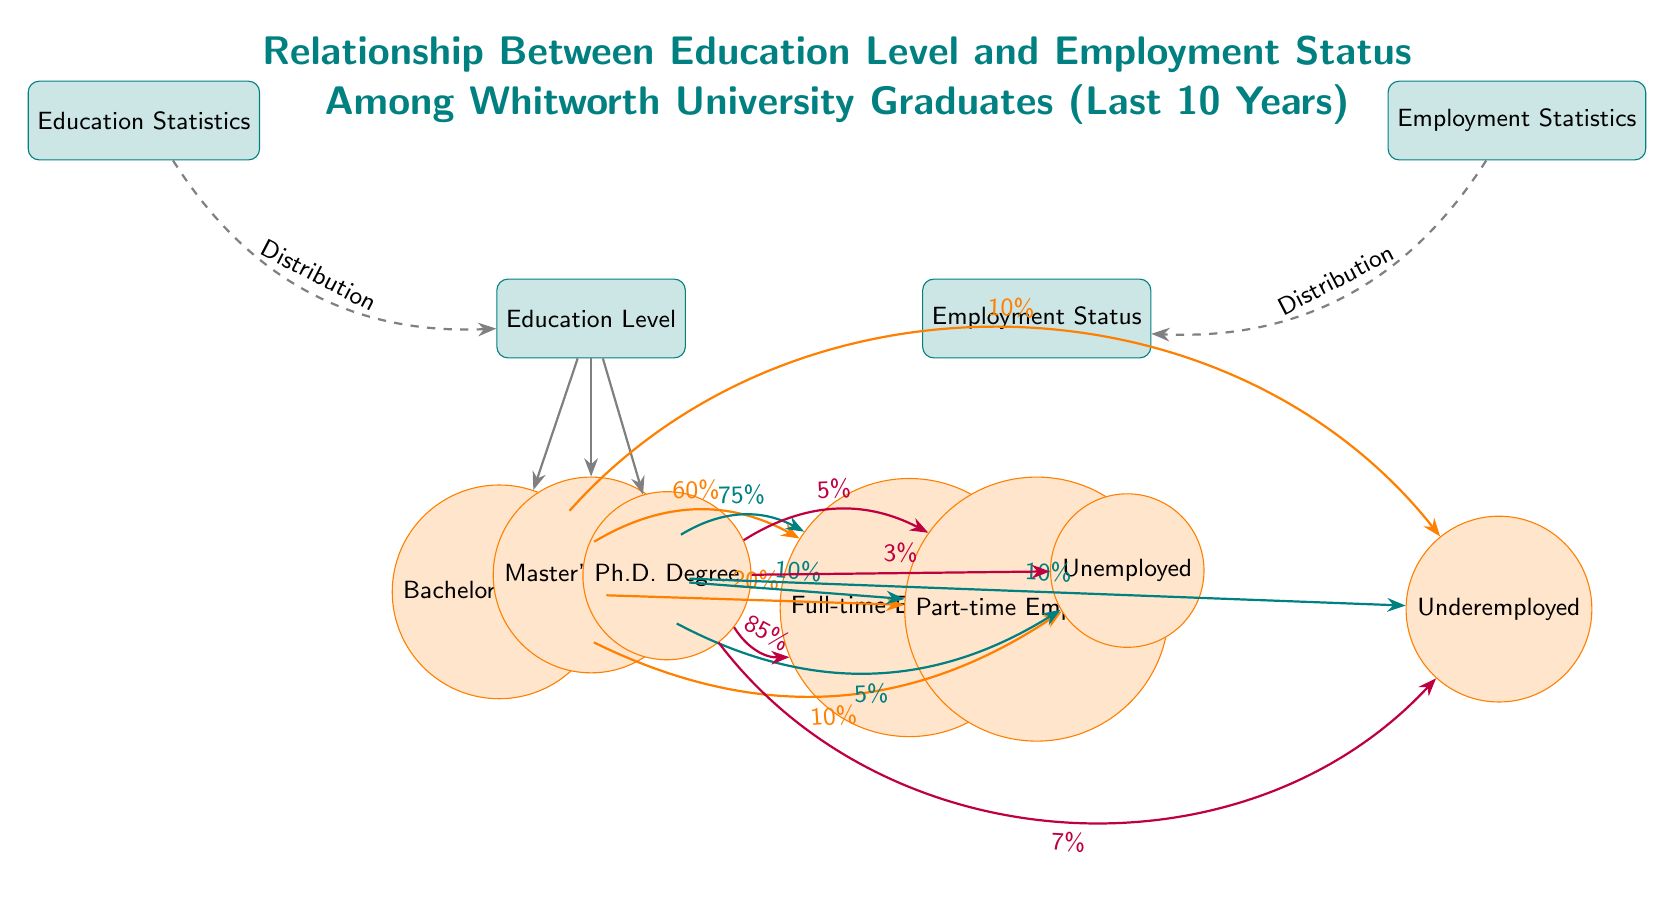What is the total number of education levels shown in the diagram? The diagram depicts three education levels: Bachelor's Degree, Master's Degree, and Ph.D. Degree.
Answer: 3 What percentage of Bachelor's Degree holders are unemployed? According to the diagram, 10% of the Bachelor's Degree holders fall into the unemployed category.
Answer: 10% Which education level leads to the lowest percentage of full-time employment? The Bachelor's Degree leads to 60% full-time employment, which is lower than the Master's (75%) and Ph.D. (85%) levels.
Answer: Bachelor's Degree How many employment statuses are represented in the diagram? The diagram illustrates four employment statuses: Full-time Employment, Part-time Employment, Unemployed, and Underemployed; thus, there are four statuses.
Answer: 4 What percentage of Master's Degree holders are underemployed? The diagram indicates that 10% of Master's Degree holders are categorized as underemployed.
Answer: 10% Which employment status has the highest percentage among Ph.D. Degree holders? The highest percentage among Ph.D. Degree holders is in Full-time Employment, with 85%.
Answer: 85% What conclusion can be drawn about employment status as education level increases? As education level increases, the percentage of individuals in Full-time Employment rises, while Unemployment rates decrease.
Answer: Increases in education lead to higher full-time employment and lower unemployment What is the connection between Education Statistics and Employment Statistics in the diagram? The connection is that both statistics show the distribution of education levels and employment statuses. They are conceptually linked by the outcomes they represent.
Answer: Distribution Which degree results in the highest rate of part-time employment? The survey shows that Bachelor's Degree holders have the highest percentage at 20%, compared to 10% for Master's and 5% for Ph.D. holders.
Answer: Bachelor's Degree 